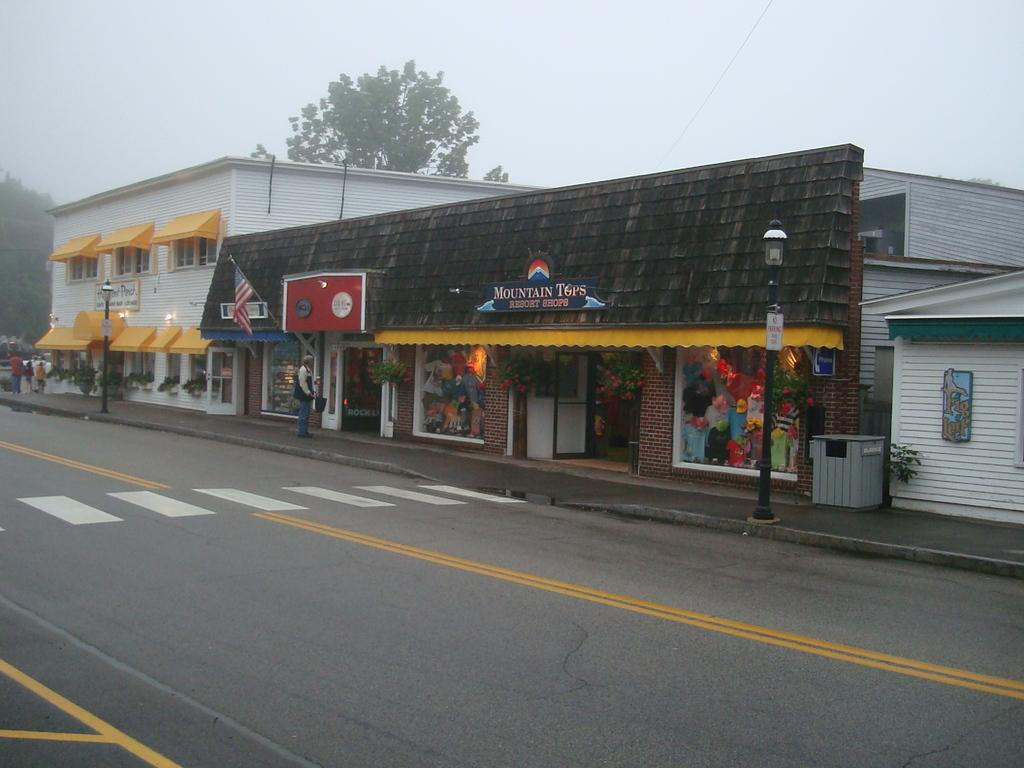What type of structures are present in the image? There are buildings in the image. What other natural elements can be seen in the image? There are trees in the image. What is located at the bottom of the image? There is a road at the bottom of the image. What objects are present in the image that might be used for supporting or holding something? There are poles visible in the image. Where is the bin located in the image? The bin is on the right side of the image. What can be seen in the background of the image? The sky is visible in the background of the image. How does the mind fold in the image? There is no mind present in the image, so it cannot fold. Is there any evidence of spying in the image? There is no indication of spying in the image. 